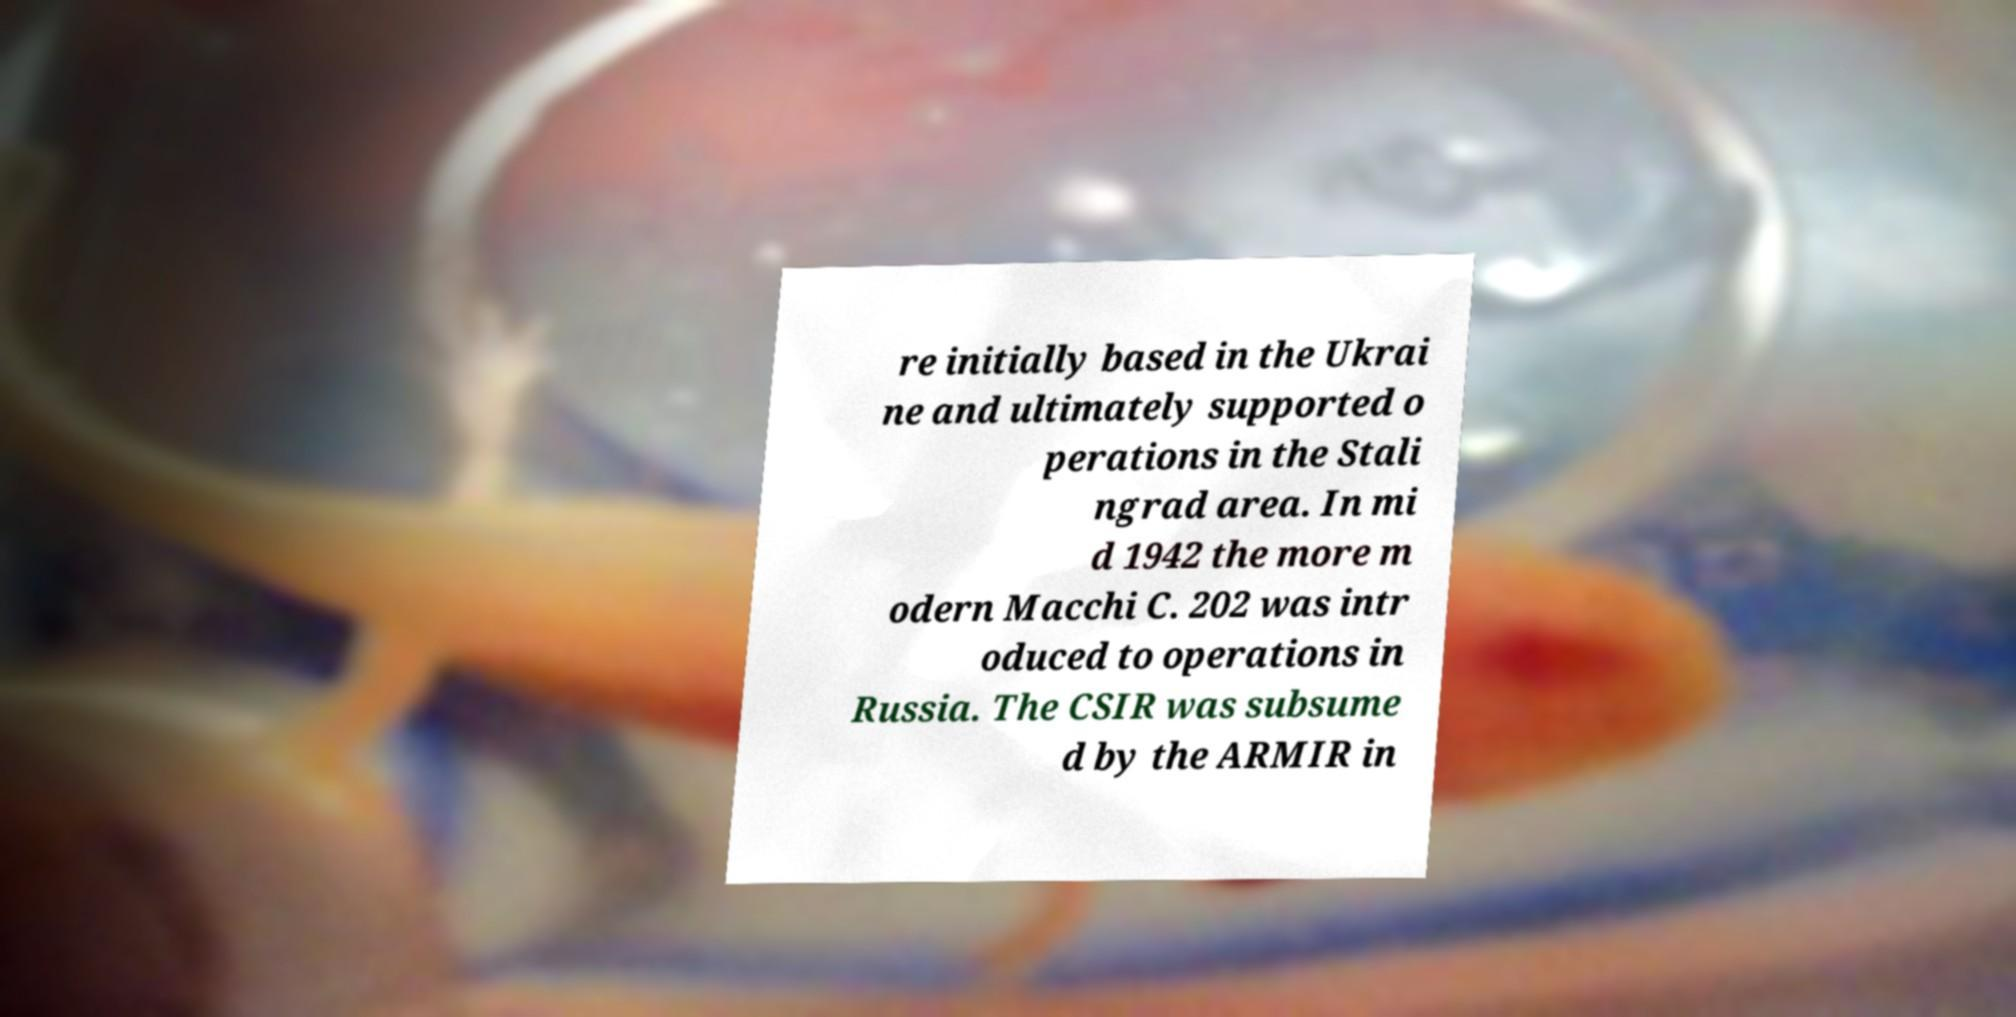Please read and relay the text visible in this image. What does it say? re initially based in the Ukrai ne and ultimately supported o perations in the Stali ngrad area. In mi d 1942 the more m odern Macchi C. 202 was intr oduced to operations in Russia. The CSIR was subsume d by the ARMIR in 